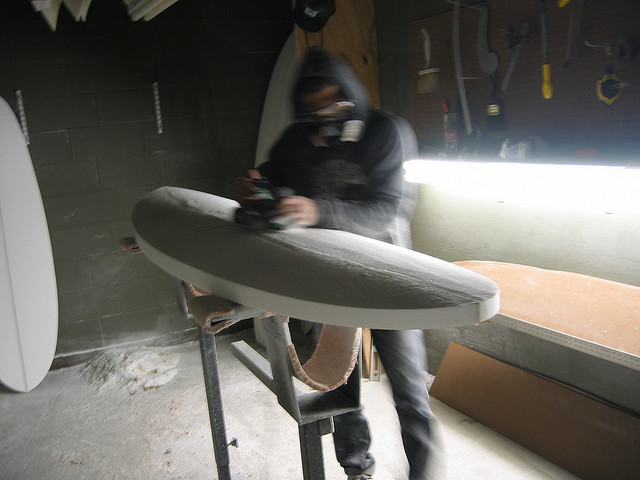What kind of environment is the man in? He's inside a shaping bay, a workspace specifically designed for crafting and finishing surfboards. This environment is typically equipped with specialized tools for shaping and is often insulated to contain dust and debris.  Why is there a bright spot to his right? The bright spot looks like a light source, possibly an overhead fluorescent light, providing illumination necessary for the detailed work of surfboard shaping. Having good lighting is essential to see imperfections and make precise adjustments. 